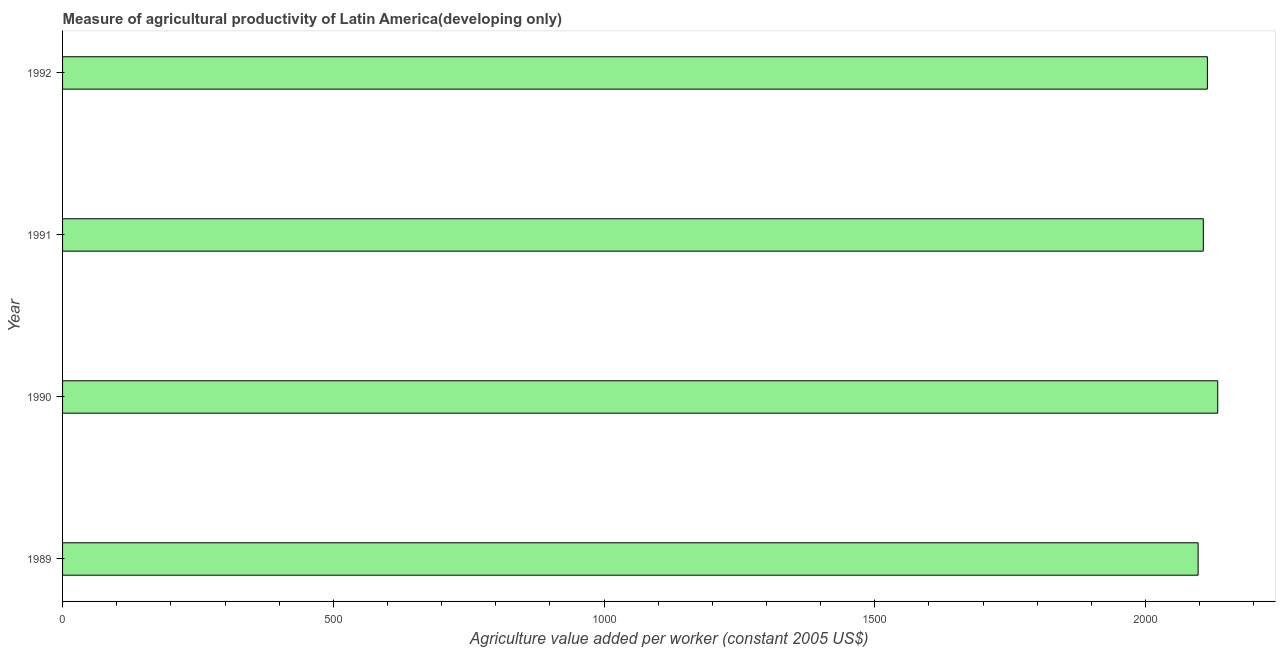Does the graph contain any zero values?
Your answer should be very brief. No. What is the title of the graph?
Ensure brevity in your answer.  Measure of agricultural productivity of Latin America(developing only). What is the label or title of the X-axis?
Your response must be concise. Agriculture value added per worker (constant 2005 US$). What is the agriculture value added per worker in 1991?
Ensure brevity in your answer.  2106.67. Across all years, what is the maximum agriculture value added per worker?
Your response must be concise. 2133.3. Across all years, what is the minimum agriculture value added per worker?
Give a very brief answer. 2097.09. In which year was the agriculture value added per worker maximum?
Make the answer very short. 1990. In which year was the agriculture value added per worker minimum?
Ensure brevity in your answer.  1989. What is the sum of the agriculture value added per worker?
Offer a very short reply. 8451.24. What is the difference between the agriculture value added per worker in 1990 and 1992?
Ensure brevity in your answer.  19.12. What is the average agriculture value added per worker per year?
Offer a very short reply. 2112.81. What is the median agriculture value added per worker?
Offer a very short reply. 2110.43. In how many years, is the agriculture value added per worker greater than 1400 US$?
Your answer should be very brief. 4. Do a majority of the years between 1991 and 1990 (inclusive) have agriculture value added per worker greater than 200 US$?
Your answer should be compact. No. What is the ratio of the agriculture value added per worker in 1990 to that in 1992?
Give a very brief answer. 1.01. What is the difference between the highest and the second highest agriculture value added per worker?
Provide a short and direct response. 19.12. Is the sum of the agriculture value added per worker in 1990 and 1992 greater than the maximum agriculture value added per worker across all years?
Your answer should be very brief. Yes. What is the difference between the highest and the lowest agriculture value added per worker?
Keep it short and to the point. 36.21. Are the values on the major ticks of X-axis written in scientific E-notation?
Ensure brevity in your answer.  No. What is the Agriculture value added per worker (constant 2005 US$) of 1989?
Provide a succinct answer. 2097.09. What is the Agriculture value added per worker (constant 2005 US$) in 1990?
Provide a succinct answer. 2133.3. What is the Agriculture value added per worker (constant 2005 US$) of 1991?
Your answer should be very brief. 2106.67. What is the Agriculture value added per worker (constant 2005 US$) in 1992?
Make the answer very short. 2114.18. What is the difference between the Agriculture value added per worker (constant 2005 US$) in 1989 and 1990?
Provide a succinct answer. -36.21. What is the difference between the Agriculture value added per worker (constant 2005 US$) in 1989 and 1991?
Offer a terse response. -9.58. What is the difference between the Agriculture value added per worker (constant 2005 US$) in 1989 and 1992?
Ensure brevity in your answer.  -17.09. What is the difference between the Agriculture value added per worker (constant 2005 US$) in 1990 and 1991?
Provide a short and direct response. 26.63. What is the difference between the Agriculture value added per worker (constant 2005 US$) in 1990 and 1992?
Keep it short and to the point. 19.12. What is the difference between the Agriculture value added per worker (constant 2005 US$) in 1991 and 1992?
Provide a short and direct response. -7.51. What is the ratio of the Agriculture value added per worker (constant 2005 US$) in 1989 to that in 1990?
Offer a very short reply. 0.98. What is the ratio of the Agriculture value added per worker (constant 2005 US$) in 1989 to that in 1991?
Your answer should be compact. 0.99. What is the ratio of the Agriculture value added per worker (constant 2005 US$) in 1990 to that in 1991?
Your response must be concise. 1.01. What is the ratio of the Agriculture value added per worker (constant 2005 US$) in 1991 to that in 1992?
Offer a terse response. 1. 